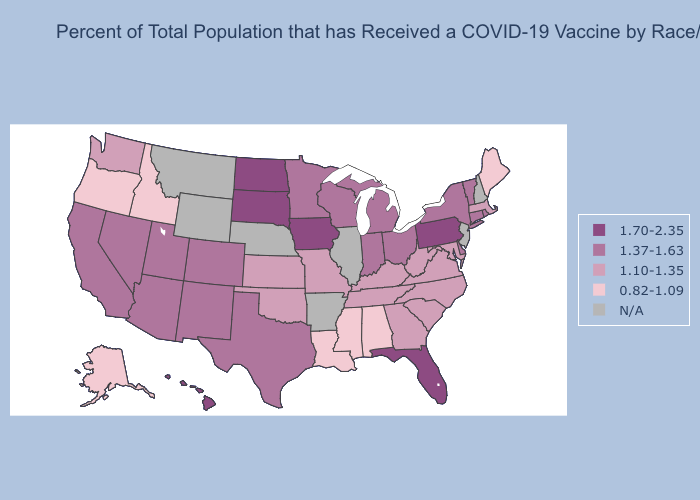What is the highest value in states that border Wisconsin?
Quick response, please. 1.70-2.35. Which states have the lowest value in the USA?
Quick response, please. Alabama, Alaska, Idaho, Louisiana, Maine, Mississippi, Oregon. What is the value of New Mexico?
Short answer required. 1.37-1.63. What is the value of Texas?
Short answer required. 1.37-1.63. Among the states that border Kansas , which have the lowest value?
Concise answer only. Missouri, Oklahoma. Does Oklahoma have the highest value in the USA?
Answer briefly. No. Name the states that have a value in the range 1.37-1.63?
Answer briefly. Arizona, California, Colorado, Connecticut, Delaware, Indiana, Michigan, Minnesota, Nevada, New Mexico, New York, Ohio, Rhode Island, Texas, Utah, Vermont, Wisconsin. What is the value of Minnesota?
Be succinct. 1.37-1.63. Name the states that have a value in the range 1.70-2.35?
Give a very brief answer. Florida, Hawaii, Iowa, North Dakota, Pennsylvania, South Dakota. What is the lowest value in the MidWest?
Write a very short answer. 1.10-1.35. Among the states that border Oklahoma , does New Mexico have the lowest value?
Be succinct. No. Name the states that have a value in the range 1.70-2.35?
Short answer required. Florida, Hawaii, Iowa, North Dakota, Pennsylvania, South Dakota. Does Alabama have the highest value in the South?
Keep it brief. No. 